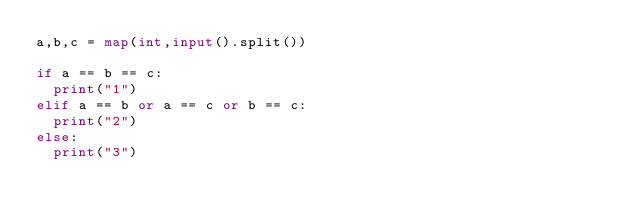Convert code to text. <code><loc_0><loc_0><loc_500><loc_500><_Python_>a,b,c = map(int,input().split())

if a == b == c:
  print("1")
elif a == b or a == c or b == c:
  print("2")
else:
  print("3")</code> 